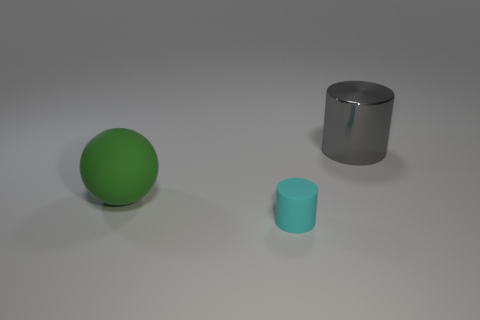Add 3 large gray things. How many objects exist? 6 Subtract all yellow cylinders. Subtract all brown blocks. How many cylinders are left? 2 Subtract all gray cylinders. How many cylinders are left? 1 Subtract all cylinders. How many objects are left? 1 Subtract all gray cylinders. How many gray spheres are left? 0 Subtract all green objects. Subtract all big metal things. How many objects are left? 1 Add 1 big green spheres. How many big green spheres are left? 2 Add 1 big blue metallic things. How many big blue metallic things exist? 1 Subtract 0 red cylinders. How many objects are left? 3 